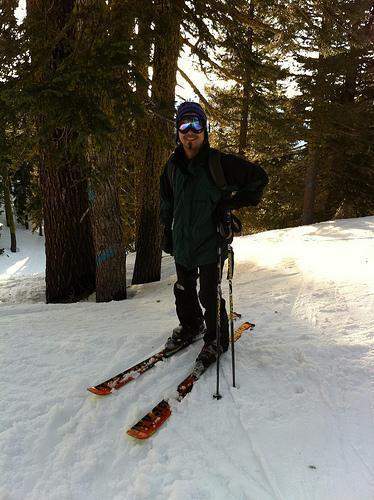How many people are in the photo?
Give a very brief answer. 1. 